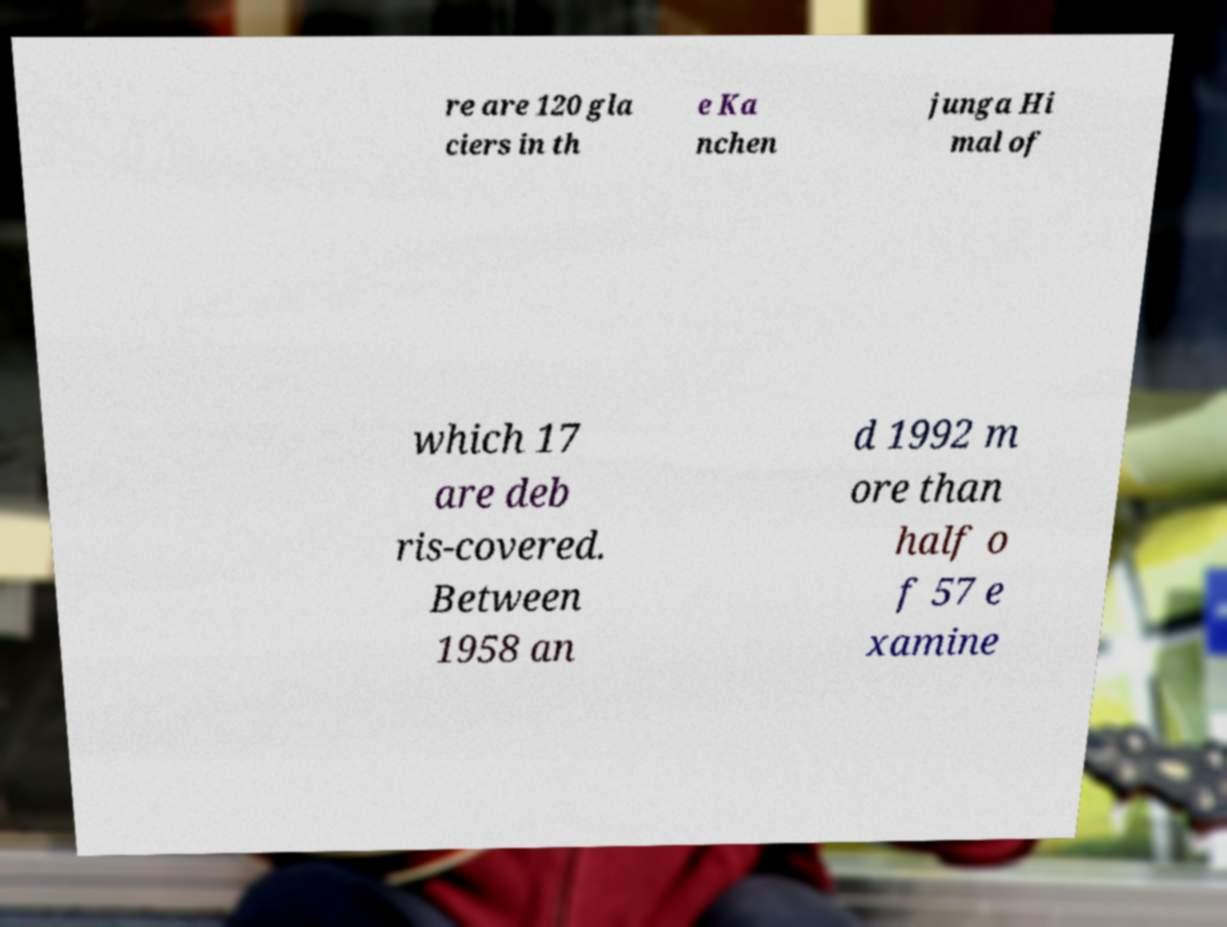There's text embedded in this image that I need extracted. Can you transcribe it verbatim? re are 120 gla ciers in th e Ka nchen junga Hi mal of which 17 are deb ris-covered. Between 1958 an d 1992 m ore than half o f 57 e xamine 